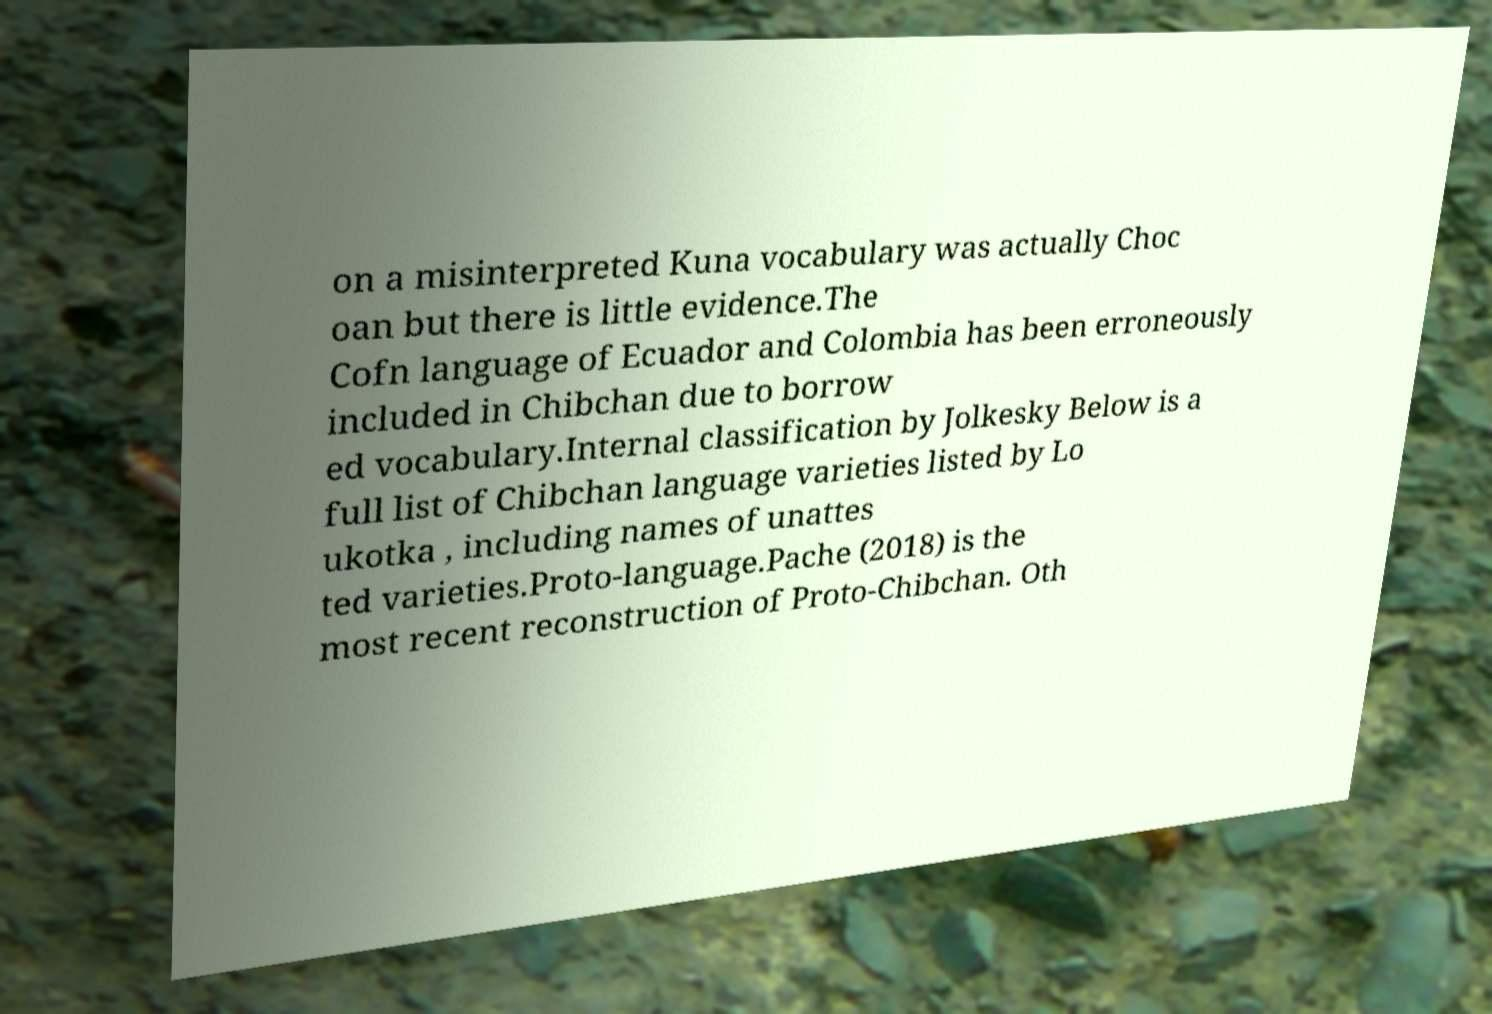Can you accurately transcribe the text from the provided image for me? on a misinterpreted Kuna vocabulary was actually Choc oan but there is little evidence.The Cofn language of Ecuador and Colombia has been erroneously included in Chibchan due to borrow ed vocabulary.Internal classification by Jolkesky Below is a full list of Chibchan language varieties listed by Lo ukotka , including names of unattes ted varieties.Proto-language.Pache (2018) is the most recent reconstruction of Proto-Chibchan. Oth 